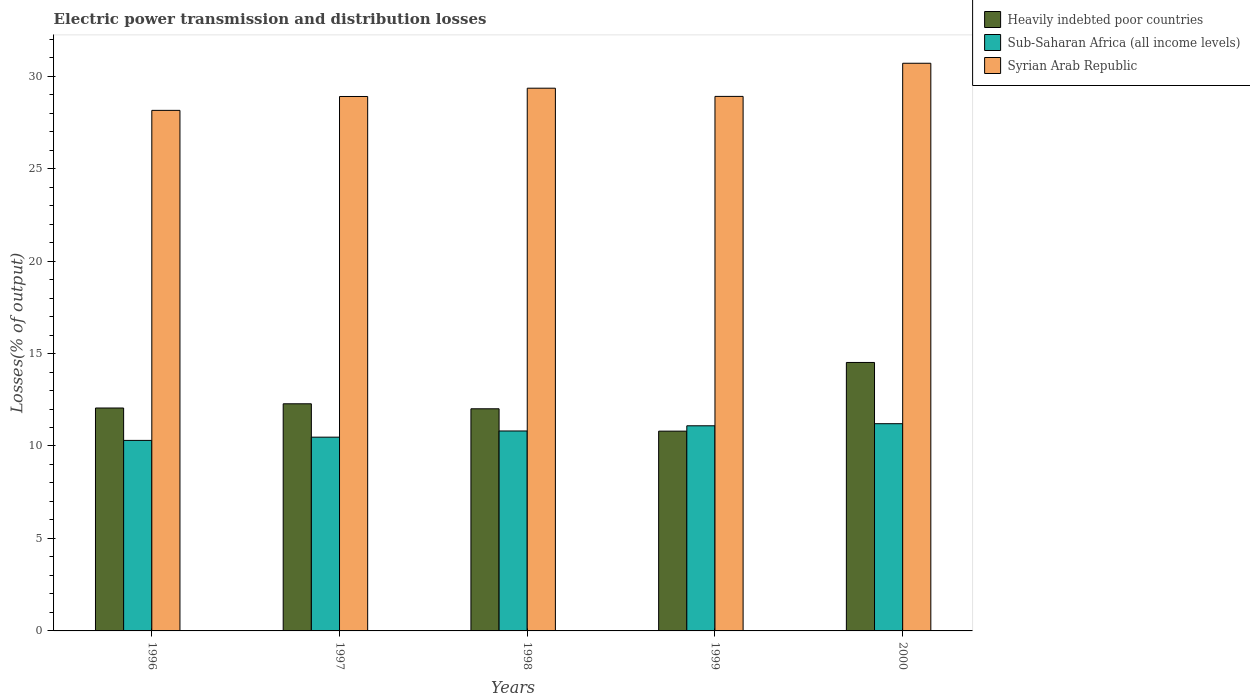How many groups of bars are there?
Your answer should be compact. 5. Are the number of bars on each tick of the X-axis equal?
Keep it short and to the point. Yes. How many bars are there on the 3rd tick from the left?
Make the answer very short. 3. In how many cases, is the number of bars for a given year not equal to the number of legend labels?
Your answer should be very brief. 0. What is the electric power transmission and distribution losses in Syrian Arab Republic in 1997?
Offer a terse response. 28.9. Across all years, what is the maximum electric power transmission and distribution losses in Sub-Saharan Africa (all income levels)?
Provide a short and direct response. 11.21. Across all years, what is the minimum electric power transmission and distribution losses in Heavily indebted poor countries?
Ensure brevity in your answer.  10.8. What is the total electric power transmission and distribution losses in Heavily indebted poor countries in the graph?
Provide a short and direct response. 61.67. What is the difference between the electric power transmission and distribution losses in Sub-Saharan Africa (all income levels) in 1997 and that in 1998?
Make the answer very short. -0.33. What is the difference between the electric power transmission and distribution losses in Sub-Saharan Africa (all income levels) in 2000 and the electric power transmission and distribution losses in Syrian Arab Republic in 1997?
Your response must be concise. -17.69. What is the average electric power transmission and distribution losses in Sub-Saharan Africa (all income levels) per year?
Your response must be concise. 10.78. In the year 2000, what is the difference between the electric power transmission and distribution losses in Sub-Saharan Africa (all income levels) and electric power transmission and distribution losses in Syrian Arab Republic?
Offer a very short reply. -19.49. In how many years, is the electric power transmission and distribution losses in Sub-Saharan Africa (all income levels) greater than 20 %?
Your answer should be very brief. 0. What is the ratio of the electric power transmission and distribution losses in Syrian Arab Republic in 1999 to that in 2000?
Make the answer very short. 0.94. What is the difference between the highest and the second highest electric power transmission and distribution losses in Sub-Saharan Africa (all income levels)?
Your answer should be compact. 0.11. What is the difference between the highest and the lowest electric power transmission and distribution losses in Sub-Saharan Africa (all income levels)?
Give a very brief answer. 0.9. In how many years, is the electric power transmission and distribution losses in Syrian Arab Republic greater than the average electric power transmission and distribution losses in Syrian Arab Republic taken over all years?
Make the answer very short. 2. Is the sum of the electric power transmission and distribution losses in Heavily indebted poor countries in 1998 and 1999 greater than the maximum electric power transmission and distribution losses in Sub-Saharan Africa (all income levels) across all years?
Your answer should be compact. Yes. What does the 3rd bar from the left in 1996 represents?
Make the answer very short. Syrian Arab Republic. What does the 3rd bar from the right in 1998 represents?
Keep it short and to the point. Heavily indebted poor countries. Is it the case that in every year, the sum of the electric power transmission and distribution losses in Sub-Saharan Africa (all income levels) and electric power transmission and distribution losses in Heavily indebted poor countries is greater than the electric power transmission and distribution losses in Syrian Arab Republic?
Your answer should be compact. No. Are all the bars in the graph horizontal?
Offer a very short reply. No. How many years are there in the graph?
Provide a succinct answer. 5. Does the graph contain any zero values?
Make the answer very short. No. Does the graph contain grids?
Provide a succinct answer. No. Where does the legend appear in the graph?
Offer a very short reply. Top right. What is the title of the graph?
Your answer should be compact. Electric power transmission and distribution losses. What is the label or title of the Y-axis?
Ensure brevity in your answer.  Losses(% of output). What is the Losses(% of output) of Heavily indebted poor countries in 1996?
Your answer should be very brief. 12.05. What is the Losses(% of output) in Sub-Saharan Africa (all income levels) in 1996?
Give a very brief answer. 10.3. What is the Losses(% of output) of Syrian Arab Republic in 1996?
Give a very brief answer. 28.15. What is the Losses(% of output) in Heavily indebted poor countries in 1997?
Give a very brief answer. 12.28. What is the Losses(% of output) in Sub-Saharan Africa (all income levels) in 1997?
Your response must be concise. 10.48. What is the Losses(% of output) of Syrian Arab Republic in 1997?
Your response must be concise. 28.9. What is the Losses(% of output) of Heavily indebted poor countries in 1998?
Provide a succinct answer. 12.01. What is the Losses(% of output) of Sub-Saharan Africa (all income levels) in 1998?
Offer a terse response. 10.81. What is the Losses(% of output) of Syrian Arab Republic in 1998?
Give a very brief answer. 29.35. What is the Losses(% of output) in Heavily indebted poor countries in 1999?
Give a very brief answer. 10.8. What is the Losses(% of output) in Sub-Saharan Africa (all income levels) in 1999?
Provide a short and direct response. 11.09. What is the Losses(% of output) of Syrian Arab Republic in 1999?
Make the answer very short. 28.91. What is the Losses(% of output) in Heavily indebted poor countries in 2000?
Provide a short and direct response. 14.52. What is the Losses(% of output) in Sub-Saharan Africa (all income levels) in 2000?
Your answer should be compact. 11.21. What is the Losses(% of output) in Syrian Arab Republic in 2000?
Your response must be concise. 30.7. Across all years, what is the maximum Losses(% of output) of Heavily indebted poor countries?
Make the answer very short. 14.52. Across all years, what is the maximum Losses(% of output) in Sub-Saharan Africa (all income levels)?
Give a very brief answer. 11.21. Across all years, what is the maximum Losses(% of output) in Syrian Arab Republic?
Offer a very short reply. 30.7. Across all years, what is the minimum Losses(% of output) of Heavily indebted poor countries?
Keep it short and to the point. 10.8. Across all years, what is the minimum Losses(% of output) in Sub-Saharan Africa (all income levels)?
Your answer should be very brief. 10.3. Across all years, what is the minimum Losses(% of output) of Syrian Arab Republic?
Offer a very short reply. 28.15. What is the total Losses(% of output) of Heavily indebted poor countries in the graph?
Keep it short and to the point. 61.67. What is the total Losses(% of output) in Sub-Saharan Africa (all income levels) in the graph?
Provide a short and direct response. 53.89. What is the total Losses(% of output) of Syrian Arab Republic in the graph?
Give a very brief answer. 146. What is the difference between the Losses(% of output) of Heavily indebted poor countries in 1996 and that in 1997?
Your answer should be very brief. -0.23. What is the difference between the Losses(% of output) of Sub-Saharan Africa (all income levels) in 1996 and that in 1997?
Make the answer very short. -0.18. What is the difference between the Losses(% of output) in Syrian Arab Republic in 1996 and that in 1997?
Your response must be concise. -0.75. What is the difference between the Losses(% of output) of Heavily indebted poor countries in 1996 and that in 1998?
Your answer should be very brief. 0.04. What is the difference between the Losses(% of output) in Sub-Saharan Africa (all income levels) in 1996 and that in 1998?
Your answer should be compact. -0.51. What is the difference between the Losses(% of output) of Syrian Arab Republic in 1996 and that in 1998?
Offer a very short reply. -1.2. What is the difference between the Losses(% of output) of Heavily indebted poor countries in 1996 and that in 1999?
Keep it short and to the point. 1.25. What is the difference between the Losses(% of output) of Sub-Saharan Africa (all income levels) in 1996 and that in 1999?
Provide a succinct answer. -0.79. What is the difference between the Losses(% of output) in Syrian Arab Republic in 1996 and that in 1999?
Provide a short and direct response. -0.76. What is the difference between the Losses(% of output) in Heavily indebted poor countries in 1996 and that in 2000?
Offer a very short reply. -2.46. What is the difference between the Losses(% of output) of Sub-Saharan Africa (all income levels) in 1996 and that in 2000?
Ensure brevity in your answer.  -0.9. What is the difference between the Losses(% of output) in Syrian Arab Republic in 1996 and that in 2000?
Your answer should be compact. -2.55. What is the difference between the Losses(% of output) in Heavily indebted poor countries in 1997 and that in 1998?
Give a very brief answer. 0.27. What is the difference between the Losses(% of output) of Sub-Saharan Africa (all income levels) in 1997 and that in 1998?
Offer a terse response. -0.33. What is the difference between the Losses(% of output) of Syrian Arab Republic in 1997 and that in 1998?
Ensure brevity in your answer.  -0.45. What is the difference between the Losses(% of output) of Heavily indebted poor countries in 1997 and that in 1999?
Provide a succinct answer. 1.48. What is the difference between the Losses(% of output) in Sub-Saharan Africa (all income levels) in 1997 and that in 1999?
Offer a very short reply. -0.62. What is the difference between the Losses(% of output) of Syrian Arab Republic in 1997 and that in 1999?
Provide a short and direct response. -0.01. What is the difference between the Losses(% of output) in Heavily indebted poor countries in 1997 and that in 2000?
Provide a succinct answer. -2.23. What is the difference between the Losses(% of output) of Sub-Saharan Africa (all income levels) in 1997 and that in 2000?
Your answer should be compact. -0.73. What is the difference between the Losses(% of output) in Syrian Arab Republic in 1997 and that in 2000?
Provide a succinct answer. -1.8. What is the difference between the Losses(% of output) in Heavily indebted poor countries in 1998 and that in 1999?
Offer a very short reply. 1.21. What is the difference between the Losses(% of output) of Sub-Saharan Africa (all income levels) in 1998 and that in 1999?
Offer a very short reply. -0.28. What is the difference between the Losses(% of output) of Syrian Arab Republic in 1998 and that in 1999?
Provide a succinct answer. 0.44. What is the difference between the Losses(% of output) of Heavily indebted poor countries in 1998 and that in 2000?
Your answer should be compact. -2.5. What is the difference between the Losses(% of output) in Sub-Saharan Africa (all income levels) in 1998 and that in 2000?
Provide a succinct answer. -0.39. What is the difference between the Losses(% of output) in Syrian Arab Republic in 1998 and that in 2000?
Offer a very short reply. -1.35. What is the difference between the Losses(% of output) in Heavily indebted poor countries in 1999 and that in 2000?
Your answer should be compact. -3.71. What is the difference between the Losses(% of output) in Sub-Saharan Africa (all income levels) in 1999 and that in 2000?
Offer a very short reply. -0.11. What is the difference between the Losses(% of output) of Syrian Arab Republic in 1999 and that in 2000?
Give a very brief answer. -1.79. What is the difference between the Losses(% of output) in Heavily indebted poor countries in 1996 and the Losses(% of output) in Sub-Saharan Africa (all income levels) in 1997?
Your answer should be compact. 1.58. What is the difference between the Losses(% of output) of Heavily indebted poor countries in 1996 and the Losses(% of output) of Syrian Arab Republic in 1997?
Your answer should be very brief. -16.85. What is the difference between the Losses(% of output) of Sub-Saharan Africa (all income levels) in 1996 and the Losses(% of output) of Syrian Arab Republic in 1997?
Ensure brevity in your answer.  -18.6. What is the difference between the Losses(% of output) in Heavily indebted poor countries in 1996 and the Losses(% of output) in Sub-Saharan Africa (all income levels) in 1998?
Your answer should be very brief. 1.24. What is the difference between the Losses(% of output) of Heavily indebted poor countries in 1996 and the Losses(% of output) of Syrian Arab Republic in 1998?
Give a very brief answer. -17.29. What is the difference between the Losses(% of output) of Sub-Saharan Africa (all income levels) in 1996 and the Losses(% of output) of Syrian Arab Republic in 1998?
Offer a very short reply. -19.05. What is the difference between the Losses(% of output) of Heavily indebted poor countries in 1996 and the Losses(% of output) of Sub-Saharan Africa (all income levels) in 1999?
Provide a short and direct response. 0.96. What is the difference between the Losses(% of output) of Heavily indebted poor countries in 1996 and the Losses(% of output) of Syrian Arab Republic in 1999?
Your answer should be very brief. -16.85. What is the difference between the Losses(% of output) in Sub-Saharan Africa (all income levels) in 1996 and the Losses(% of output) in Syrian Arab Republic in 1999?
Give a very brief answer. -18.6. What is the difference between the Losses(% of output) in Heavily indebted poor countries in 1996 and the Losses(% of output) in Sub-Saharan Africa (all income levels) in 2000?
Provide a short and direct response. 0.85. What is the difference between the Losses(% of output) in Heavily indebted poor countries in 1996 and the Losses(% of output) in Syrian Arab Republic in 2000?
Keep it short and to the point. -18.64. What is the difference between the Losses(% of output) of Sub-Saharan Africa (all income levels) in 1996 and the Losses(% of output) of Syrian Arab Republic in 2000?
Provide a succinct answer. -20.39. What is the difference between the Losses(% of output) of Heavily indebted poor countries in 1997 and the Losses(% of output) of Sub-Saharan Africa (all income levels) in 1998?
Offer a very short reply. 1.47. What is the difference between the Losses(% of output) in Heavily indebted poor countries in 1997 and the Losses(% of output) in Syrian Arab Republic in 1998?
Give a very brief answer. -17.07. What is the difference between the Losses(% of output) of Sub-Saharan Africa (all income levels) in 1997 and the Losses(% of output) of Syrian Arab Republic in 1998?
Provide a short and direct response. -18.87. What is the difference between the Losses(% of output) in Heavily indebted poor countries in 1997 and the Losses(% of output) in Sub-Saharan Africa (all income levels) in 1999?
Keep it short and to the point. 1.19. What is the difference between the Losses(% of output) of Heavily indebted poor countries in 1997 and the Losses(% of output) of Syrian Arab Republic in 1999?
Make the answer very short. -16.62. What is the difference between the Losses(% of output) of Sub-Saharan Africa (all income levels) in 1997 and the Losses(% of output) of Syrian Arab Republic in 1999?
Keep it short and to the point. -18.43. What is the difference between the Losses(% of output) in Heavily indebted poor countries in 1997 and the Losses(% of output) in Sub-Saharan Africa (all income levels) in 2000?
Ensure brevity in your answer.  1.08. What is the difference between the Losses(% of output) in Heavily indebted poor countries in 1997 and the Losses(% of output) in Syrian Arab Republic in 2000?
Ensure brevity in your answer.  -18.41. What is the difference between the Losses(% of output) of Sub-Saharan Africa (all income levels) in 1997 and the Losses(% of output) of Syrian Arab Republic in 2000?
Provide a short and direct response. -20.22. What is the difference between the Losses(% of output) in Heavily indebted poor countries in 1998 and the Losses(% of output) in Sub-Saharan Africa (all income levels) in 1999?
Keep it short and to the point. 0.92. What is the difference between the Losses(% of output) in Heavily indebted poor countries in 1998 and the Losses(% of output) in Syrian Arab Republic in 1999?
Offer a very short reply. -16.89. What is the difference between the Losses(% of output) in Sub-Saharan Africa (all income levels) in 1998 and the Losses(% of output) in Syrian Arab Republic in 1999?
Offer a terse response. -18.09. What is the difference between the Losses(% of output) in Heavily indebted poor countries in 1998 and the Losses(% of output) in Sub-Saharan Africa (all income levels) in 2000?
Provide a succinct answer. 0.81. What is the difference between the Losses(% of output) of Heavily indebted poor countries in 1998 and the Losses(% of output) of Syrian Arab Republic in 2000?
Give a very brief answer. -18.68. What is the difference between the Losses(% of output) of Sub-Saharan Africa (all income levels) in 1998 and the Losses(% of output) of Syrian Arab Republic in 2000?
Keep it short and to the point. -19.88. What is the difference between the Losses(% of output) of Heavily indebted poor countries in 1999 and the Losses(% of output) of Sub-Saharan Africa (all income levels) in 2000?
Your answer should be very brief. -0.4. What is the difference between the Losses(% of output) in Heavily indebted poor countries in 1999 and the Losses(% of output) in Syrian Arab Republic in 2000?
Offer a terse response. -19.89. What is the difference between the Losses(% of output) of Sub-Saharan Africa (all income levels) in 1999 and the Losses(% of output) of Syrian Arab Republic in 2000?
Provide a short and direct response. -19.6. What is the average Losses(% of output) of Heavily indebted poor countries per year?
Offer a terse response. 12.33. What is the average Losses(% of output) in Sub-Saharan Africa (all income levels) per year?
Give a very brief answer. 10.78. What is the average Losses(% of output) in Syrian Arab Republic per year?
Give a very brief answer. 29.2. In the year 1996, what is the difference between the Losses(% of output) in Heavily indebted poor countries and Losses(% of output) in Sub-Saharan Africa (all income levels)?
Keep it short and to the point. 1.75. In the year 1996, what is the difference between the Losses(% of output) in Heavily indebted poor countries and Losses(% of output) in Syrian Arab Republic?
Offer a terse response. -16.1. In the year 1996, what is the difference between the Losses(% of output) in Sub-Saharan Africa (all income levels) and Losses(% of output) in Syrian Arab Republic?
Keep it short and to the point. -17.85. In the year 1997, what is the difference between the Losses(% of output) of Heavily indebted poor countries and Losses(% of output) of Sub-Saharan Africa (all income levels)?
Your answer should be very brief. 1.8. In the year 1997, what is the difference between the Losses(% of output) of Heavily indebted poor countries and Losses(% of output) of Syrian Arab Republic?
Ensure brevity in your answer.  -16.62. In the year 1997, what is the difference between the Losses(% of output) of Sub-Saharan Africa (all income levels) and Losses(% of output) of Syrian Arab Republic?
Provide a short and direct response. -18.42. In the year 1998, what is the difference between the Losses(% of output) of Heavily indebted poor countries and Losses(% of output) of Sub-Saharan Africa (all income levels)?
Your answer should be compact. 1.2. In the year 1998, what is the difference between the Losses(% of output) of Heavily indebted poor countries and Losses(% of output) of Syrian Arab Republic?
Offer a very short reply. -17.34. In the year 1998, what is the difference between the Losses(% of output) in Sub-Saharan Africa (all income levels) and Losses(% of output) in Syrian Arab Republic?
Provide a succinct answer. -18.54. In the year 1999, what is the difference between the Losses(% of output) in Heavily indebted poor countries and Losses(% of output) in Sub-Saharan Africa (all income levels)?
Your answer should be very brief. -0.29. In the year 1999, what is the difference between the Losses(% of output) in Heavily indebted poor countries and Losses(% of output) in Syrian Arab Republic?
Provide a short and direct response. -18.1. In the year 1999, what is the difference between the Losses(% of output) of Sub-Saharan Africa (all income levels) and Losses(% of output) of Syrian Arab Republic?
Keep it short and to the point. -17.81. In the year 2000, what is the difference between the Losses(% of output) in Heavily indebted poor countries and Losses(% of output) in Sub-Saharan Africa (all income levels)?
Give a very brief answer. 3.31. In the year 2000, what is the difference between the Losses(% of output) of Heavily indebted poor countries and Losses(% of output) of Syrian Arab Republic?
Provide a succinct answer. -16.18. In the year 2000, what is the difference between the Losses(% of output) of Sub-Saharan Africa (all income levels) and Losses(% of output) of Syrian Arab Republic?
Your response must be concise. -19.49. What is the ratio of the Losses(% of output) of Heavily indebted poor countries in 1996 to that in 1997?
Your response must be concise. 0.98. What is the ratio of the Losses(% of output) in Sub-Saharan Africa (all income levels) in 1996 to that in 1997?
Provide a succinct answer. 0.98. What is the ratio of the Losses(% of output) in Sub-Saharan Africa (all income levels) in 1996 to that in 1998?
Your answer should be compact. 0.95. What is the ratio of the Losses(% of output) of Syrian Arab Republic in 1996 to that in 1998?
Offer a very short reply. 0.96. What is the ratio of the Losses(% of output) of Heavily indebted poor countries in 1996 to that in 1999?
Ensure brevity in your answer.  1.12. What is the ratio of the Losses(% of output) of Sub-Saharan Africa (all income levels) in 1996 to that in 1999?
Provide a short and direct response. 0.93. What is the ratio of the Losses(% of output) of Syrian Arab Republic in 1996 to that in 1999?
Make the answer very short. 0.97. What is the ratio of the Losses(% of output) in Heavily indebted poor countries in 1996 to that in 2000?
Your response must be concise. 0.83. What is the ratio of the Losses(% of output) in Sub-Saharan Africa (all income levels) in 1996 to that in 2000?
Provide a succinct answer. 0.92. What is the ratio of the Losses(% of output) in Syrian Arab Republic in 1996 to that in 2000?
Keep it short and to the point. 0.92. What is the ratio of the Losses(% of output) in Heavily indebted poor countries in 1997 to that in 1998?
Give a very brief answer. 1.02. What is the ratio of the Losses(% of output) of Sub-Saharan Africa (all income levels) in 1997 to that in 1998?
Provide a succinct answer. 0.97. What is the ratio of the Losses(% of output) of Syrian Arab Republic in 1997 to that in 1998?
Your response must be concise. 0.98. What is the ratio of the Losses(% of output) of Heavily indebted poor countries in 1997 to that in 1999?
Give a very brief answer. 1.14. What is the ratio of the Losses(% of output) of Sub-Saharan Africa (all income levels) in 1997 to that in 1999?
Keep it short and to the point. 0.94. What is the ratio of the Losses(% of output) of Heavily indebted poor countries in 1997 to that in 2000?
Make the answer very short. 0.85. What is the ratio of the Losses(% of output) of Sub-Saharan Africa (all income levels) in 1997 to that in 2000?
Your answer should be very brief. 0.94. What is the ratio of the Losses(% of output) of Syrian Arab Republic in 1997 to that in 2000?
Your answer should be very brief. 0.94. What is the ratio of the Losses(% of output) in Heavily indebted poor countries in 1998 to that in 1999?
Provide a succinct answer. 1.11. What is the ratio of the Losses(% of output) of Sub-Saharan Africa (all income levels) in 1998 to that in 1999?
Provide a succinct answer. 0.97. What is the ratio of the Losses(% of output) in Syrian Arab Republic in 1998 to that in 1999?
Make the answer very short. 1.02. What is the ratio of the Losses(% of output) of Heavily indebted poor countries in 1998 to that in 2000?
Provide a short and direct response. 0.83. What is the ratio of the Losses(% of output) in Sub-Saharan Africa (all income levels) in 1998 to that in 2000?
Provide a succinct answer. 0.96. What is the ratio of the Losses(% of output) in Syrian Arab Republic in 1998 to that in 2000?
Ensure brevity in your answer.  0.96. What is the ratio of the Losses(% of output) in Heavily indebted poor countries in 1999 to that in 2000?
Give a very brief answer. 0.74. What is the ratio of the Losses(% of output) of Syrian Arab Republic in 1999 to that in 2000?
Your answer should be very brief. 0.94. What is the difference between the highest and the second highest Losses(% of output) in Heavily indebted poor countries?
Provide a succinct answer. 2.23. What is the difference between the highest and the second highest Losses(% of output) in Sub-Saharan Africa (all income levels)?
Keep it short and to the point. 0.11. What is the difference between the highest and the second highest Losses(% of output) in Syrian Arab Republic?
Give a very brief answer. 1.35. What is the difference between the highest and the lowest Losses(% of output) in Heavily indebted poor countries?
Your response must be concise. 3.71. What is the difference between the highest and the lowest Losses(% of output) in Sub-Saharan Africa (all income levels)?
Make the answer very short. 0.9. What is the difference between the highest and the lowest Losses(% of output) of Syrian Arab Republic?
Provide a short and direct response. 2.55. 